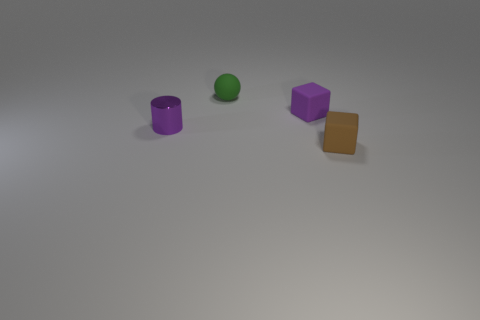Subtract all cylinders. How many objects are left? 3 Add 4 matte things. How many objects exist? 8 Subtract 1 cylinders. How many cylinders are left? 0 Subtract all cyan balls. Subtract all cyan blocks. How many balls are left? 1 Subtract all cyan balls. How many purple blocks are left? 1 Subtract all yellow rubber balls. Subtract all green rubber things. How many objects are left? 3 Add 2 small brown cubes. How many small brown cubes are left? 3 Add 3 large blue cubes. How many large blue cubes exist? 3 Subtract all purple blocks. How many blocks are left? 1 Subtract 1 brown blocks. How many objects are left? 3 